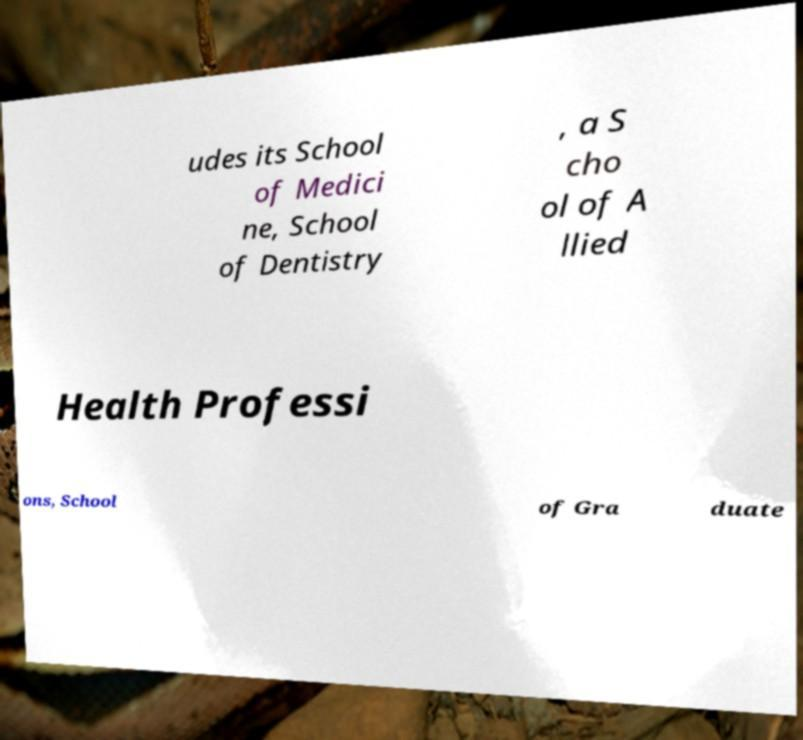Could you extract and type out the text from this image? udes its School of Medici ne, School of Dentistry , a S cho ol of A llied Health Professi ons, School of Gra duate 